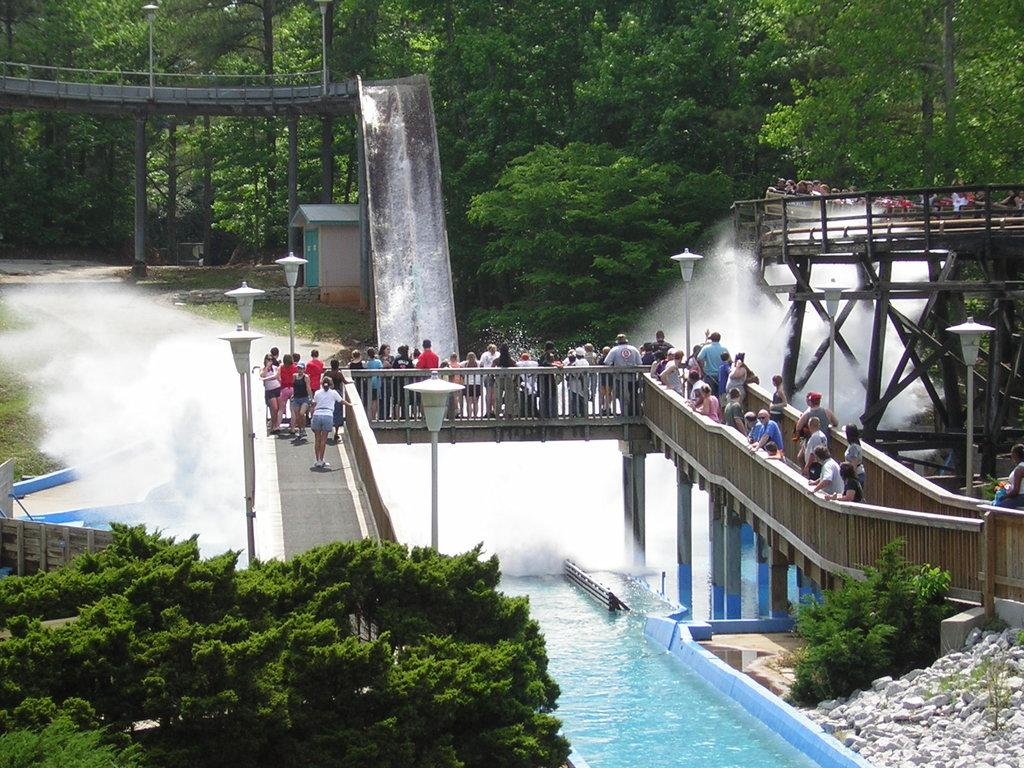What are the people in the image doing? There are persons standing on the bridge in the image. What type of recreational facility can be seen in the image? Water slides are present in the image. What type of urban infrastructure is visible in the image? Street poles and street lights are present in the image. What type of body of water is visible in the image? There is a pool in the image. What type of vegetation is present in the image? Trees are present in the image. What type of natural material is visible in the image? Stones are visible in the image. What type of surface is visible in the image? The ground is visible in the image. Can you tell me how many times the person sneezes in the image? There is no person sneezing in the image. What shape does the circle take in the image? There is no circle present in the image. 